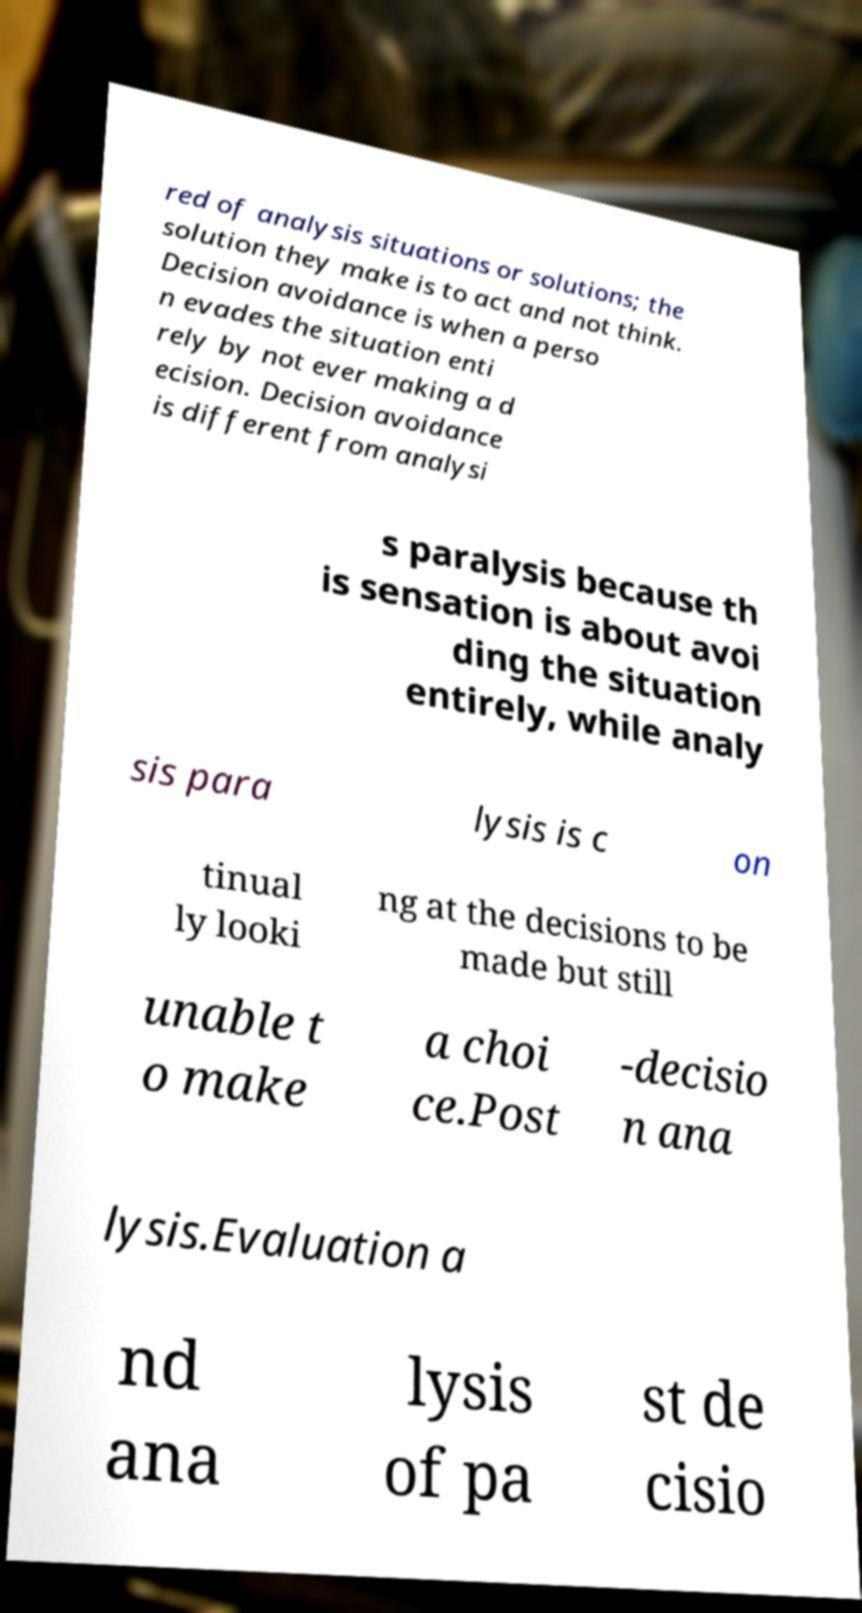Can you read and provide the text displayed in the image?This photo seems to have some interesting text. Can you extract and type it out for me? red of analysis situations or solutions; the solution they make is to act and not think. Decision avoidance is when a perso n evades the situation enti rely by not ever making a d ecision. Decision avoidance is different from analysi s paralysis because th is sensation is about avoi ding the situation entirely, while analy sis para lysis is c on tinual ly looki ng at the decisions to be made but still unable t o make a choi ce.Post -decisio n ana lysis.Evaluation a nd ana lysis of pa st de cisio 